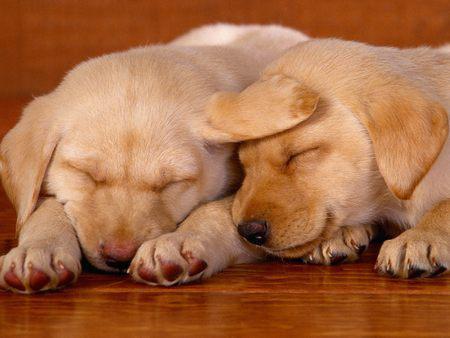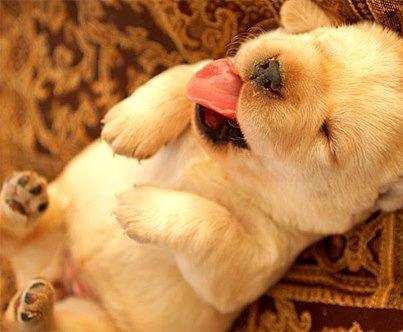The first image is the image on the left, the second image is the image on the right. Assess this claim about the two images: "some dogs are sleeping and some are not.". Correct or not? Answer yes or no. No. The first image is the image on the left, the second image is the image on the right. Evaluate the accuracy of this statement regarding the images: "Two dogs of similar coloring are snoozing with heads touching on a wood-grained surface.". Is it true? Answer yes or no. Yes. 